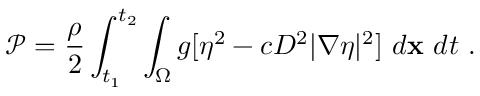<formula> <loc_0><loc_0><loc_500><loc_500>\mathcal { P } = \frac { \rho } { 2 } \int _ { t _ { 1 } } ^ { t _ { 2 } } \int _ { \Omega } g [ \eta ^ { 2 } - c D ^ { 2 } | \nabla \eta | ^ { 2 } ] d x d t \ .</formula> 